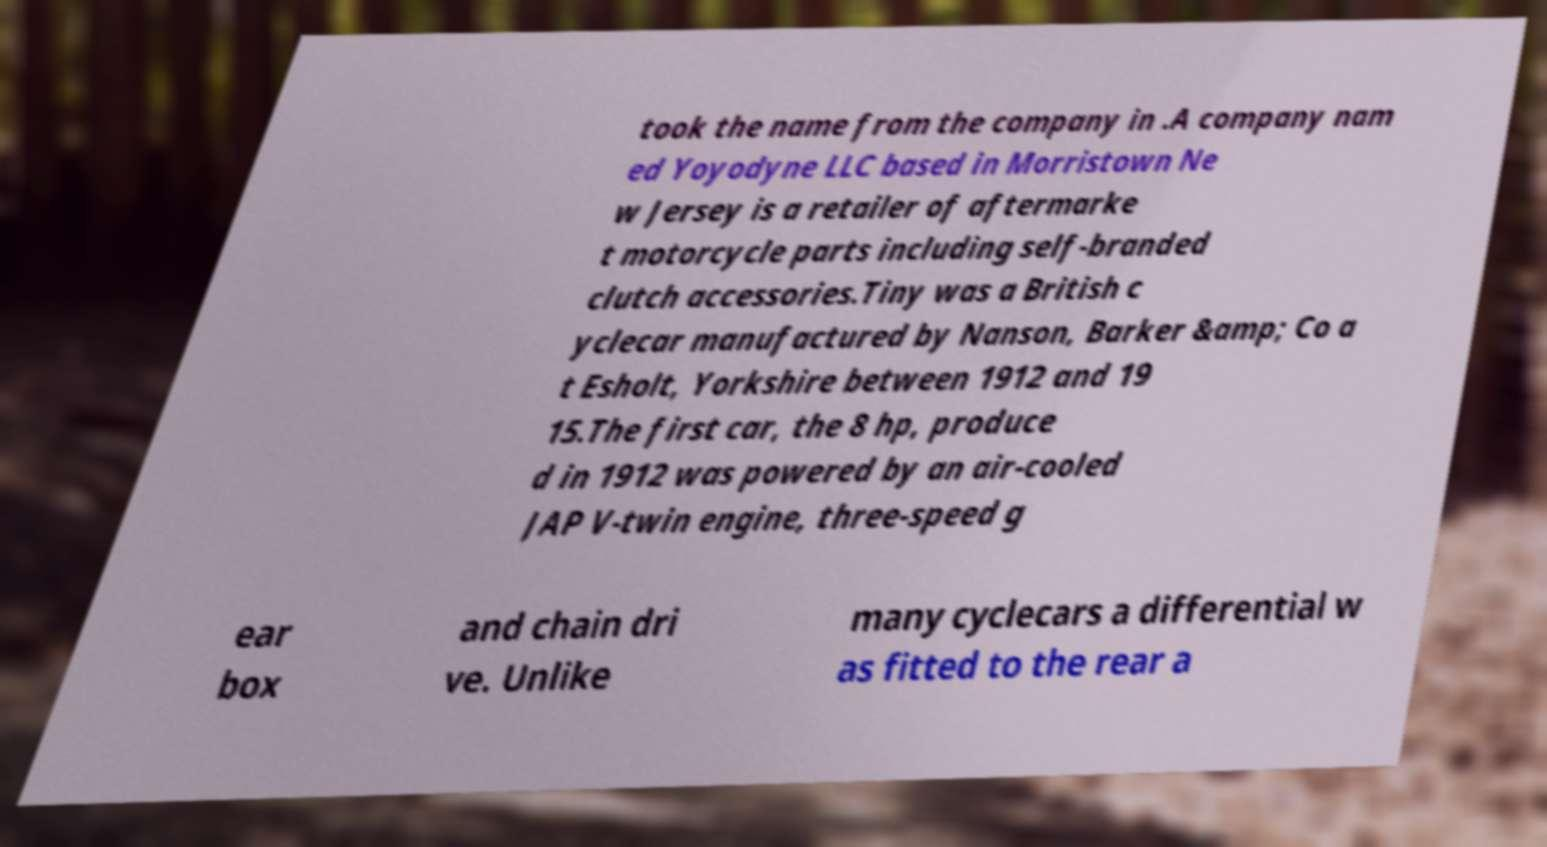Please identify and transcribe the text found in this image. took the name from the company in .A company nam ed Yoyodyne LLC based in Morristown Ne w Jersey is a retailer of aftermarke t motorcycle parts including self-branded clutch accessories.Tiny was a British c yclecar manufactured by Nanson, Barker &amp; Co a t Esholt, Yorkshire between 1912 and 19 15.The first car, the 8 hp, produce d in 1912 was powered by an air-cooled JAP V-twin engine, three-speed g ear box and chain dri ve. Unlike many cyclecars a differential w as fitted to the rear a 